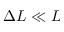<formula> <loc_0><loc_0><loc_500><loc_500>\Delta L \ll L</formula> 